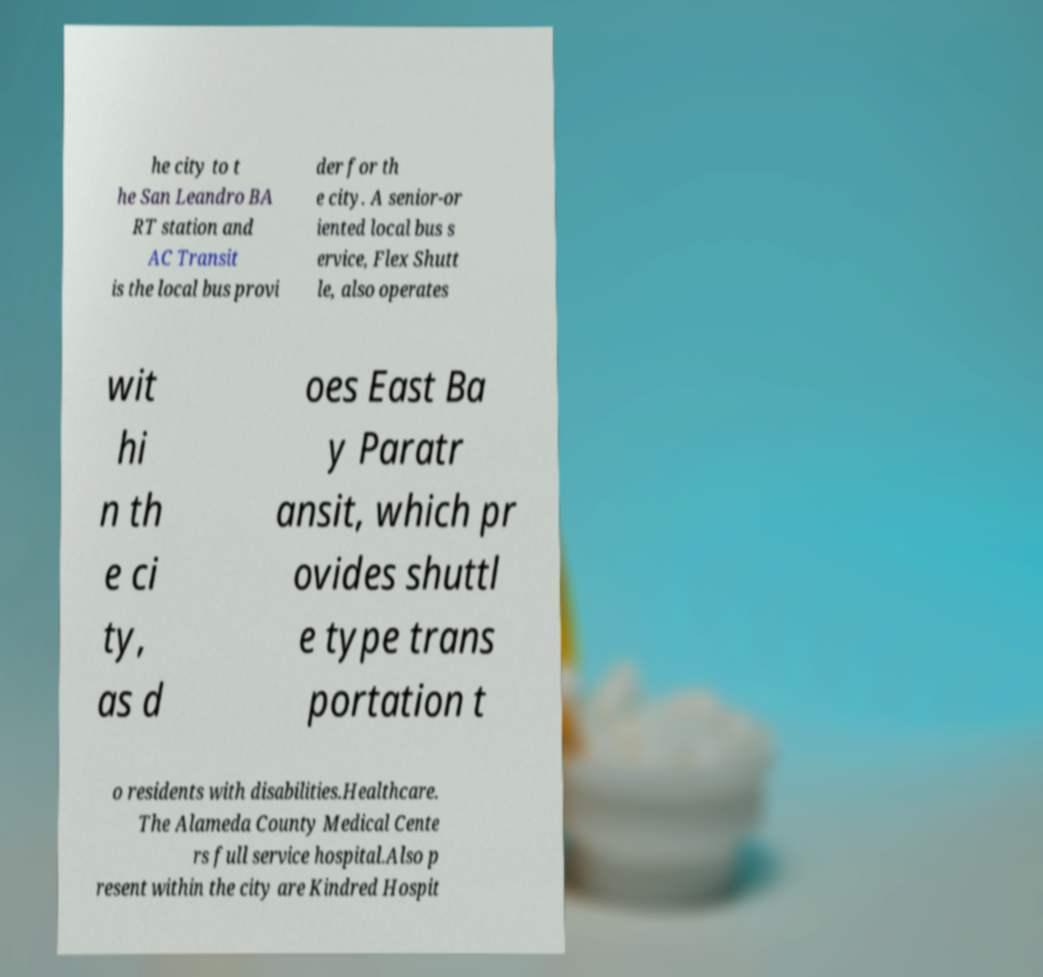There's text embedded in this image that I need extracted. Can you transcribe it verbatim? he city to t he San Leandro BA RT station and AC Transit is the local bus provi der for th e city. A senior-or iented local bus s ervice, Flex Shutt le, also operates wit hi n th e ci ty, as d oes East Ba y Paratr ansit, which pr ovides shuttl e type trans portation t o residents with disabilities.Healthcare. The Alameda County Medical Cente rs full service hospital.Also p resent within the city are Kindred Hospit 